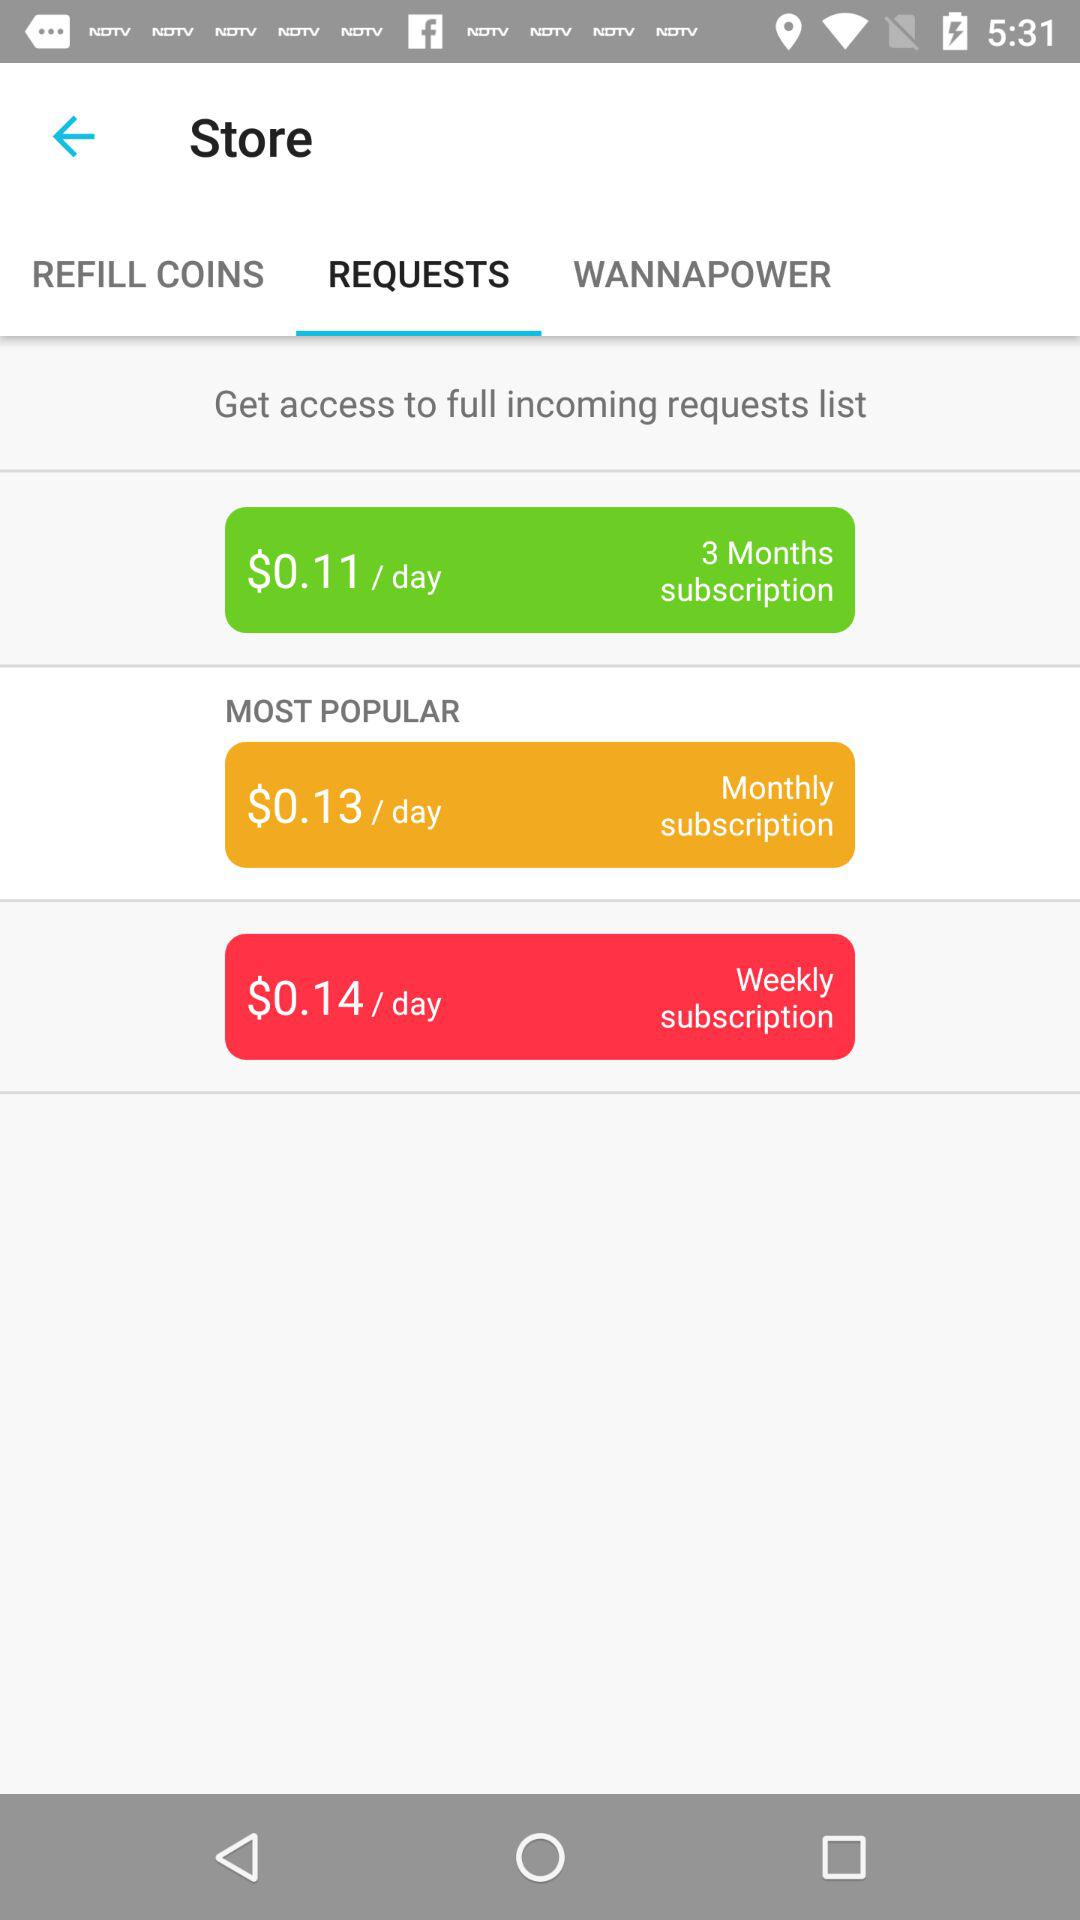What is the per-day cost for the weekly subscription? The per-day cost for the weekly subscription is $0.14. 